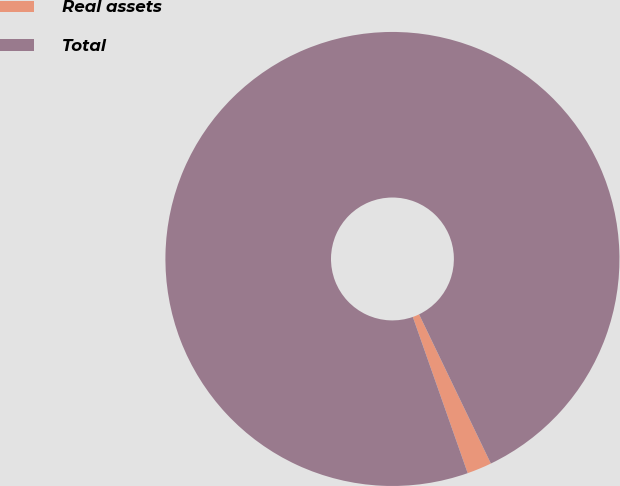Convert chart to OTSL. <chart><loc_0><loc_0><loc_500><loc_500><pie_chart><fcel>Real assets<fcel>Total<nl><fcel>1.76%<fcel>98.24%<nl></chart> 